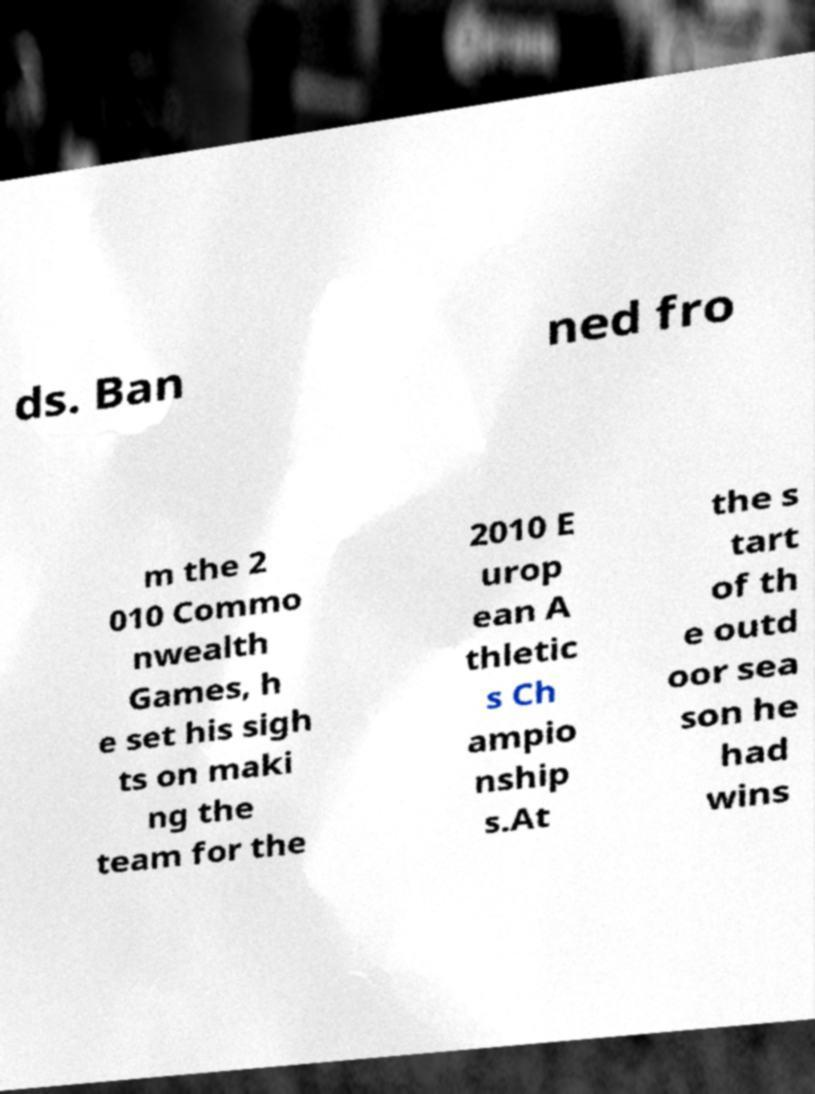Could you assist in decoding the text presented in this image and type it out clearly? ds. Ban ned fro m the 2 010 Commo nwealth Games, h e set his sigh ts on maki ng the team for the 2010 E urop ean A thletic s Ch ampio nship s.At the s tart of th e outd oor sea son he had wins 